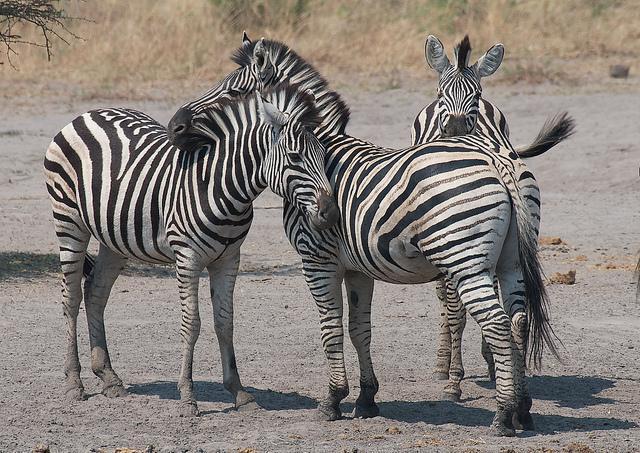How many zebras have dirty hoofs?
Give a very brief answer. 3. How many zebra are standing in the dirt?
Give a very brief answer. 3. How many zebras are in the picture?
Give a very brief answer. 3. How many zebras are there?
Give a very brief answer. 3. How many brown horses are in the grass?
Give a very brief answer. 0. 